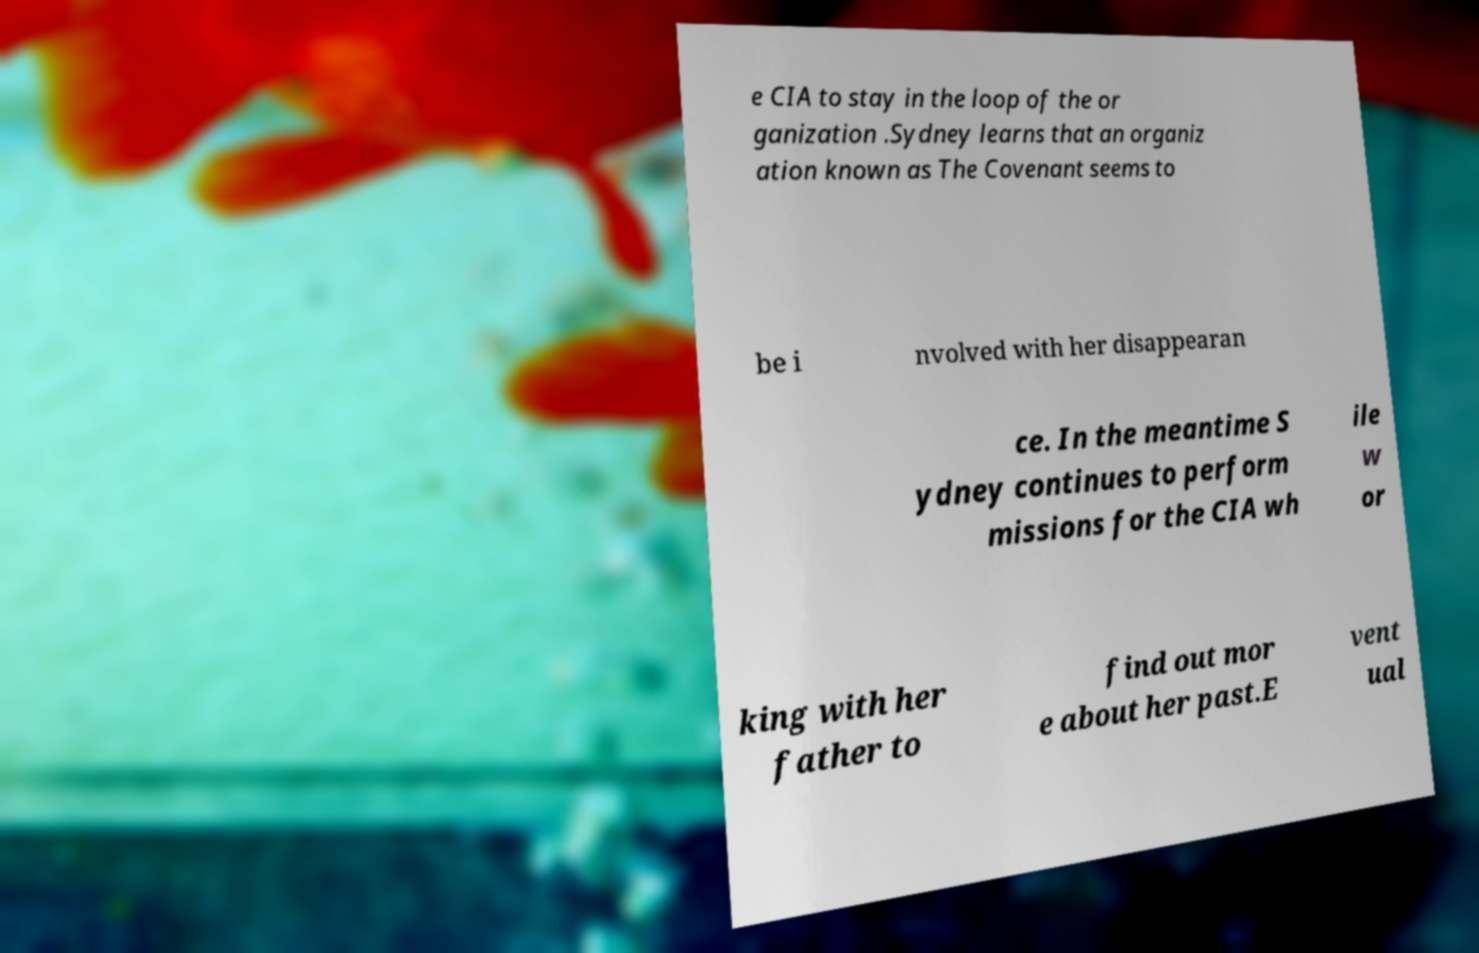What messages or text are displayed in this image? I need them in a readable, typed format. e CIA to stay in the loop of the or ganization .Sydney learns that an organiz ation known as The Covenant seems to be i nvolved with her disappearan ce. In the meantime S ydney continues to perform missions for the CIA wh ile w or king with her father to find out mor e about her past.E vent ual 